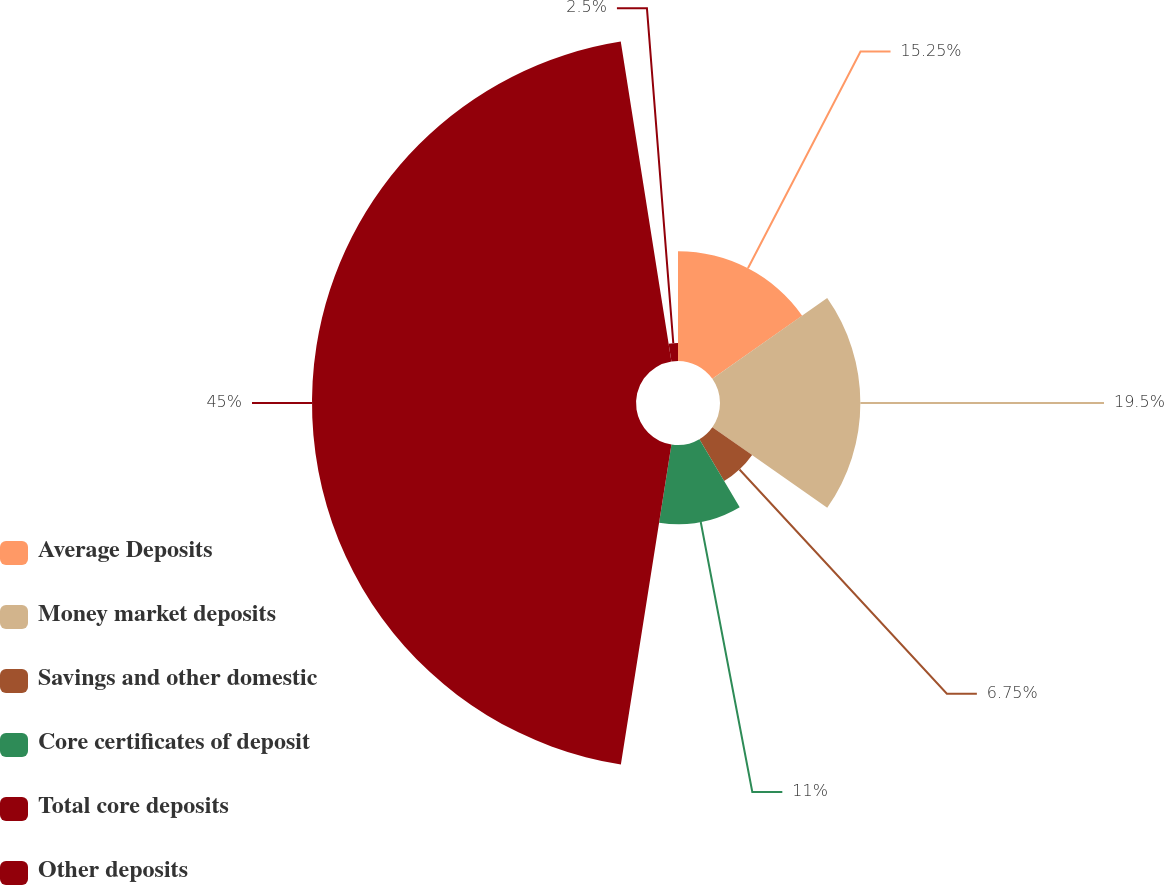Convert chart. <chart><loc_0><loc_0><loc_500><loc_500><pie_chart><fcel>Average Deposits<fcel>Money market deposits<fcel>Savings and other domestic<fcel>Core certificates of deposit<fcel>Total core deposits<fcel>Other deposits<nl><fcel>15.25%<fcel>19.5%<fcel>6.75%<fcel>11.0%<fcel>45.01%<fcel>2.5%<nl></chart> 